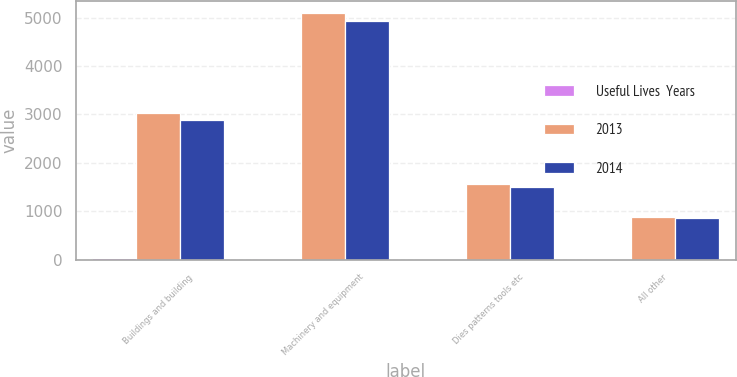Convert chart to OTSL. <chart><loc_0><loc_0><loc_500><loc_500><stacked_bar_chart><ecel><fcel>Buildings and building<fcel>Machinery and equipment<fcel>Dies patterns tools etc<fcel>All other<nl><fcel>Useful Lives  Years<fcel>23<fcel>11<fcel>8<fcel>5<nl><fcel>2013<fcel>3037<fcel>5089<fcel>1552<fcel>889<nl><fcel>2014<fcel>2875<fcel>4931<fcel>1492<fcel>866<nl></chart> 